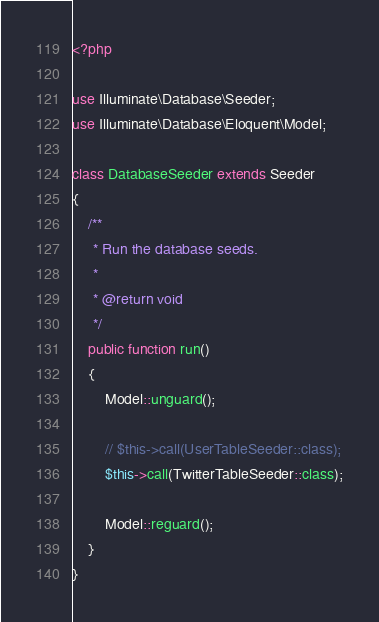<code> <loc_0><loc_0><loc_500><loc_500><_PHP_><?php

use Illuminate\Database\Seeder;
use Illuminate\Database\Eloquent\Model;

class DatabaseSeeder extends Seeder
{
    /**
     * Run the database seeds.
     *
     * @return void
     */
    public function run()
    {
        Model::unguard();

        // $this->call(UserTableSeeder::class);
        $this->call(TwitterTableSeeder::class);

        Model::reguard();
    }
}
</code> 